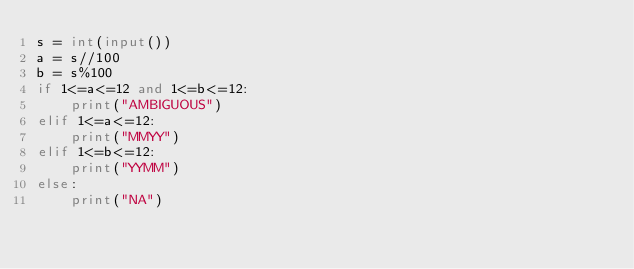<code> <loc_0><loc_0><loc_500><loc_500><_Python_>s = int(input())
a = s//100
b = s%100
if 1<=a<=12 and 1<=b<=12:
    print("AMBIGUOUS")
elif 1<=a<=12:
    print("MMYY")
elif 1<=b<=12:
    print("YYMM")
else:
    print("NA")
</code> 